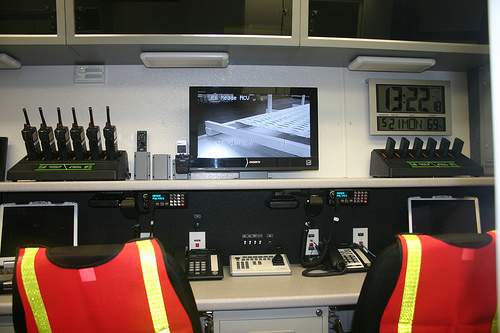<image>
Is the clock on the desk? No. The clock is not positioned on the desk. They may be near each other, but the clock is not supported by or resting on top of the desk. 